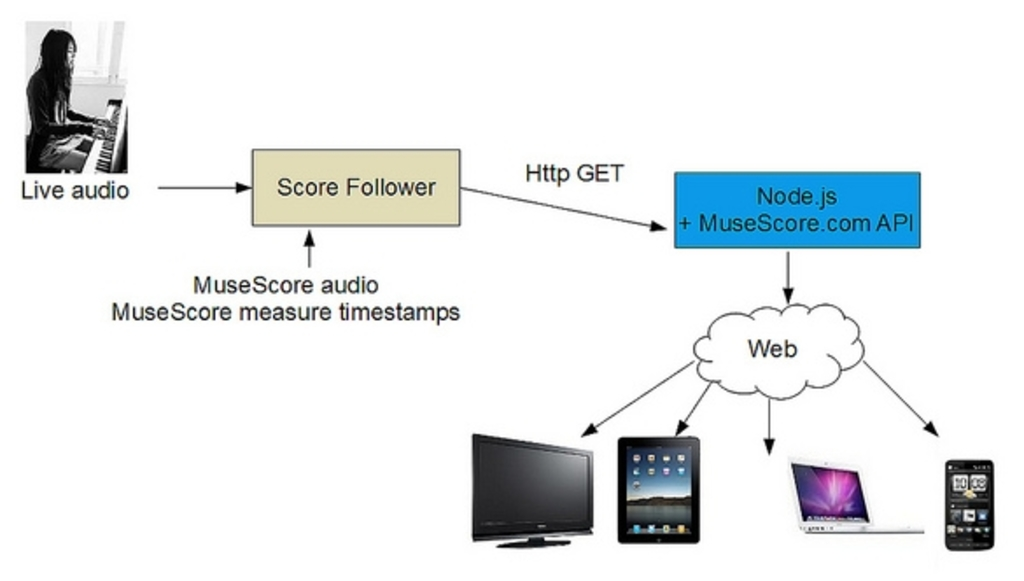What is the function of the Score Follower in this flowchart, and how might it impact the user experience? The Score Follower plays a pivotal role in synchronizing live audio input with MuseScore’s digital scores by assigning timestamps to each sound, aligning the music's live performance with its digital sheet representation. This function enhances user experience by providing real-time feedback and visualization, which is essential for educational purposes and performance improvements. The integration ensures users can correct, practice, or perform with accurate musical guidance. 